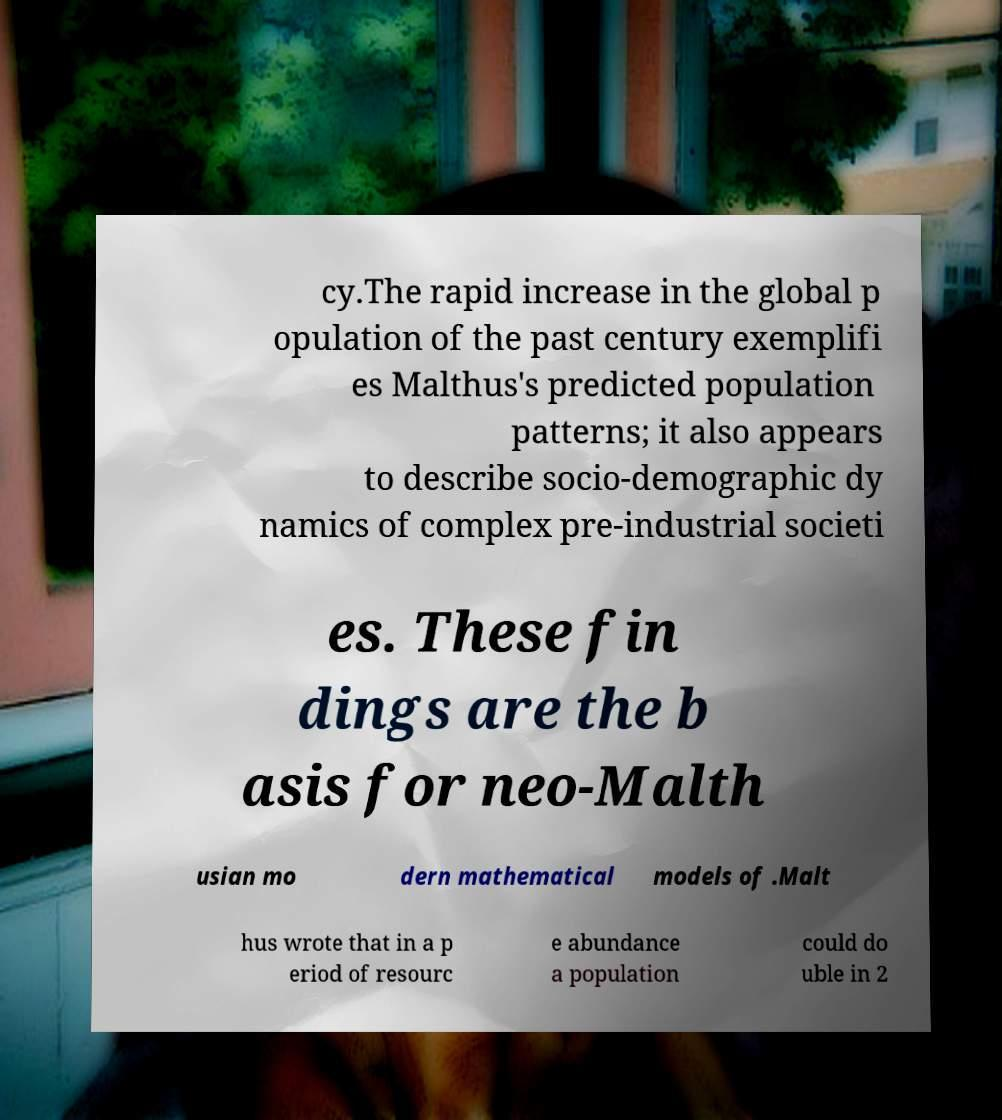Please read and relay the text visible in this image. What does it say? cy.The rapid increase in the global p opulation of the past century exemplifi es Malthus's predicted population patterns; it also appears to describe socio-demographic dy namics of complex pre-industrial societi es. These fin dings are the b asis for neo-Malth usian mo dern mathematical models of .Malt hus wrote that in a p eriod of resourc e abundance a population could do uble in 2 